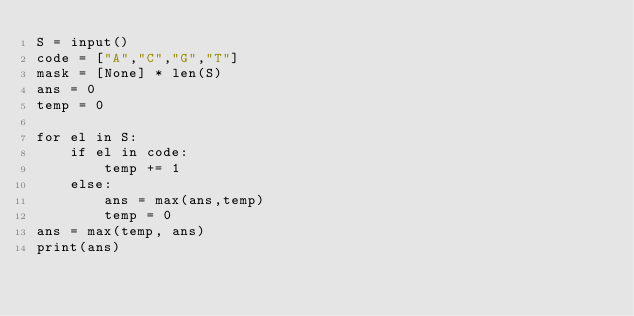<code> <loc_0><loc_0><loc_500><loc_500><_Python_>S = input()
code = ["A","C","G","T"]
mask = [None] * len(S)
ans = 0
temp = 0

for el in S:
    if el in code:
        temp += 1
    else:
        ans = max(ans,temp)
        temp = 0
ans = max(temp, ans)
print(ans)    </code> 